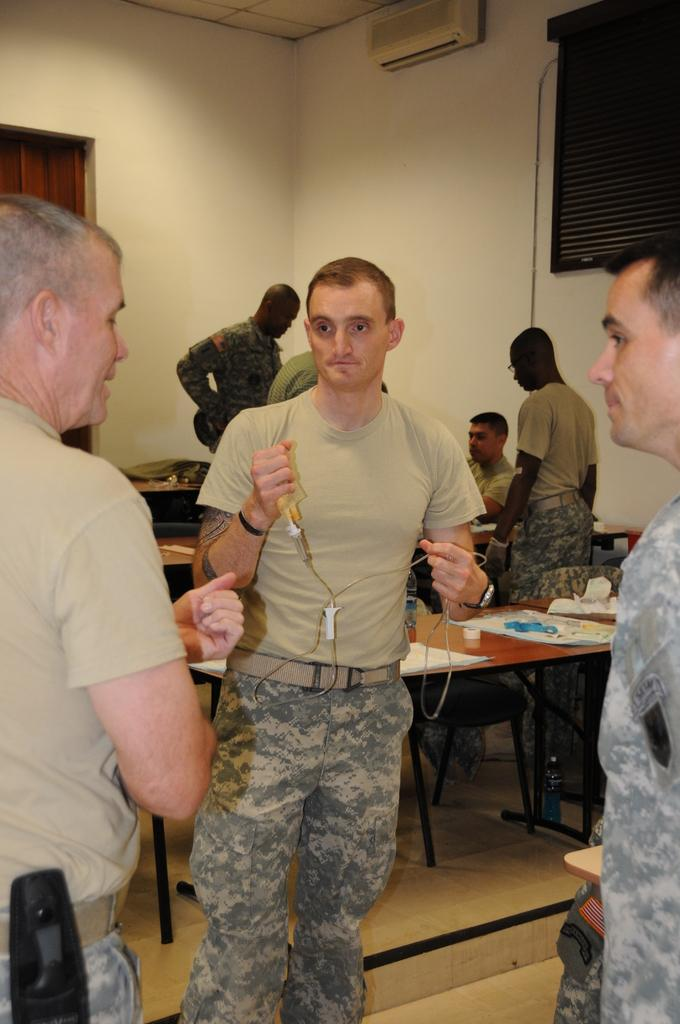What is the color of the wall in the image? The wall in the image is white. What are the people in the image doing? The people in the image are sitting and standing. What type of furniture is present in the image? There are benches in the image. What can be seen on the wall in the image? There is a window in the image. Can you see a tiger or a zebra in the image? No, there are no tigers or zebras present in the image. Are there any wings visible in the image? No, there are no wings visible in the image. 